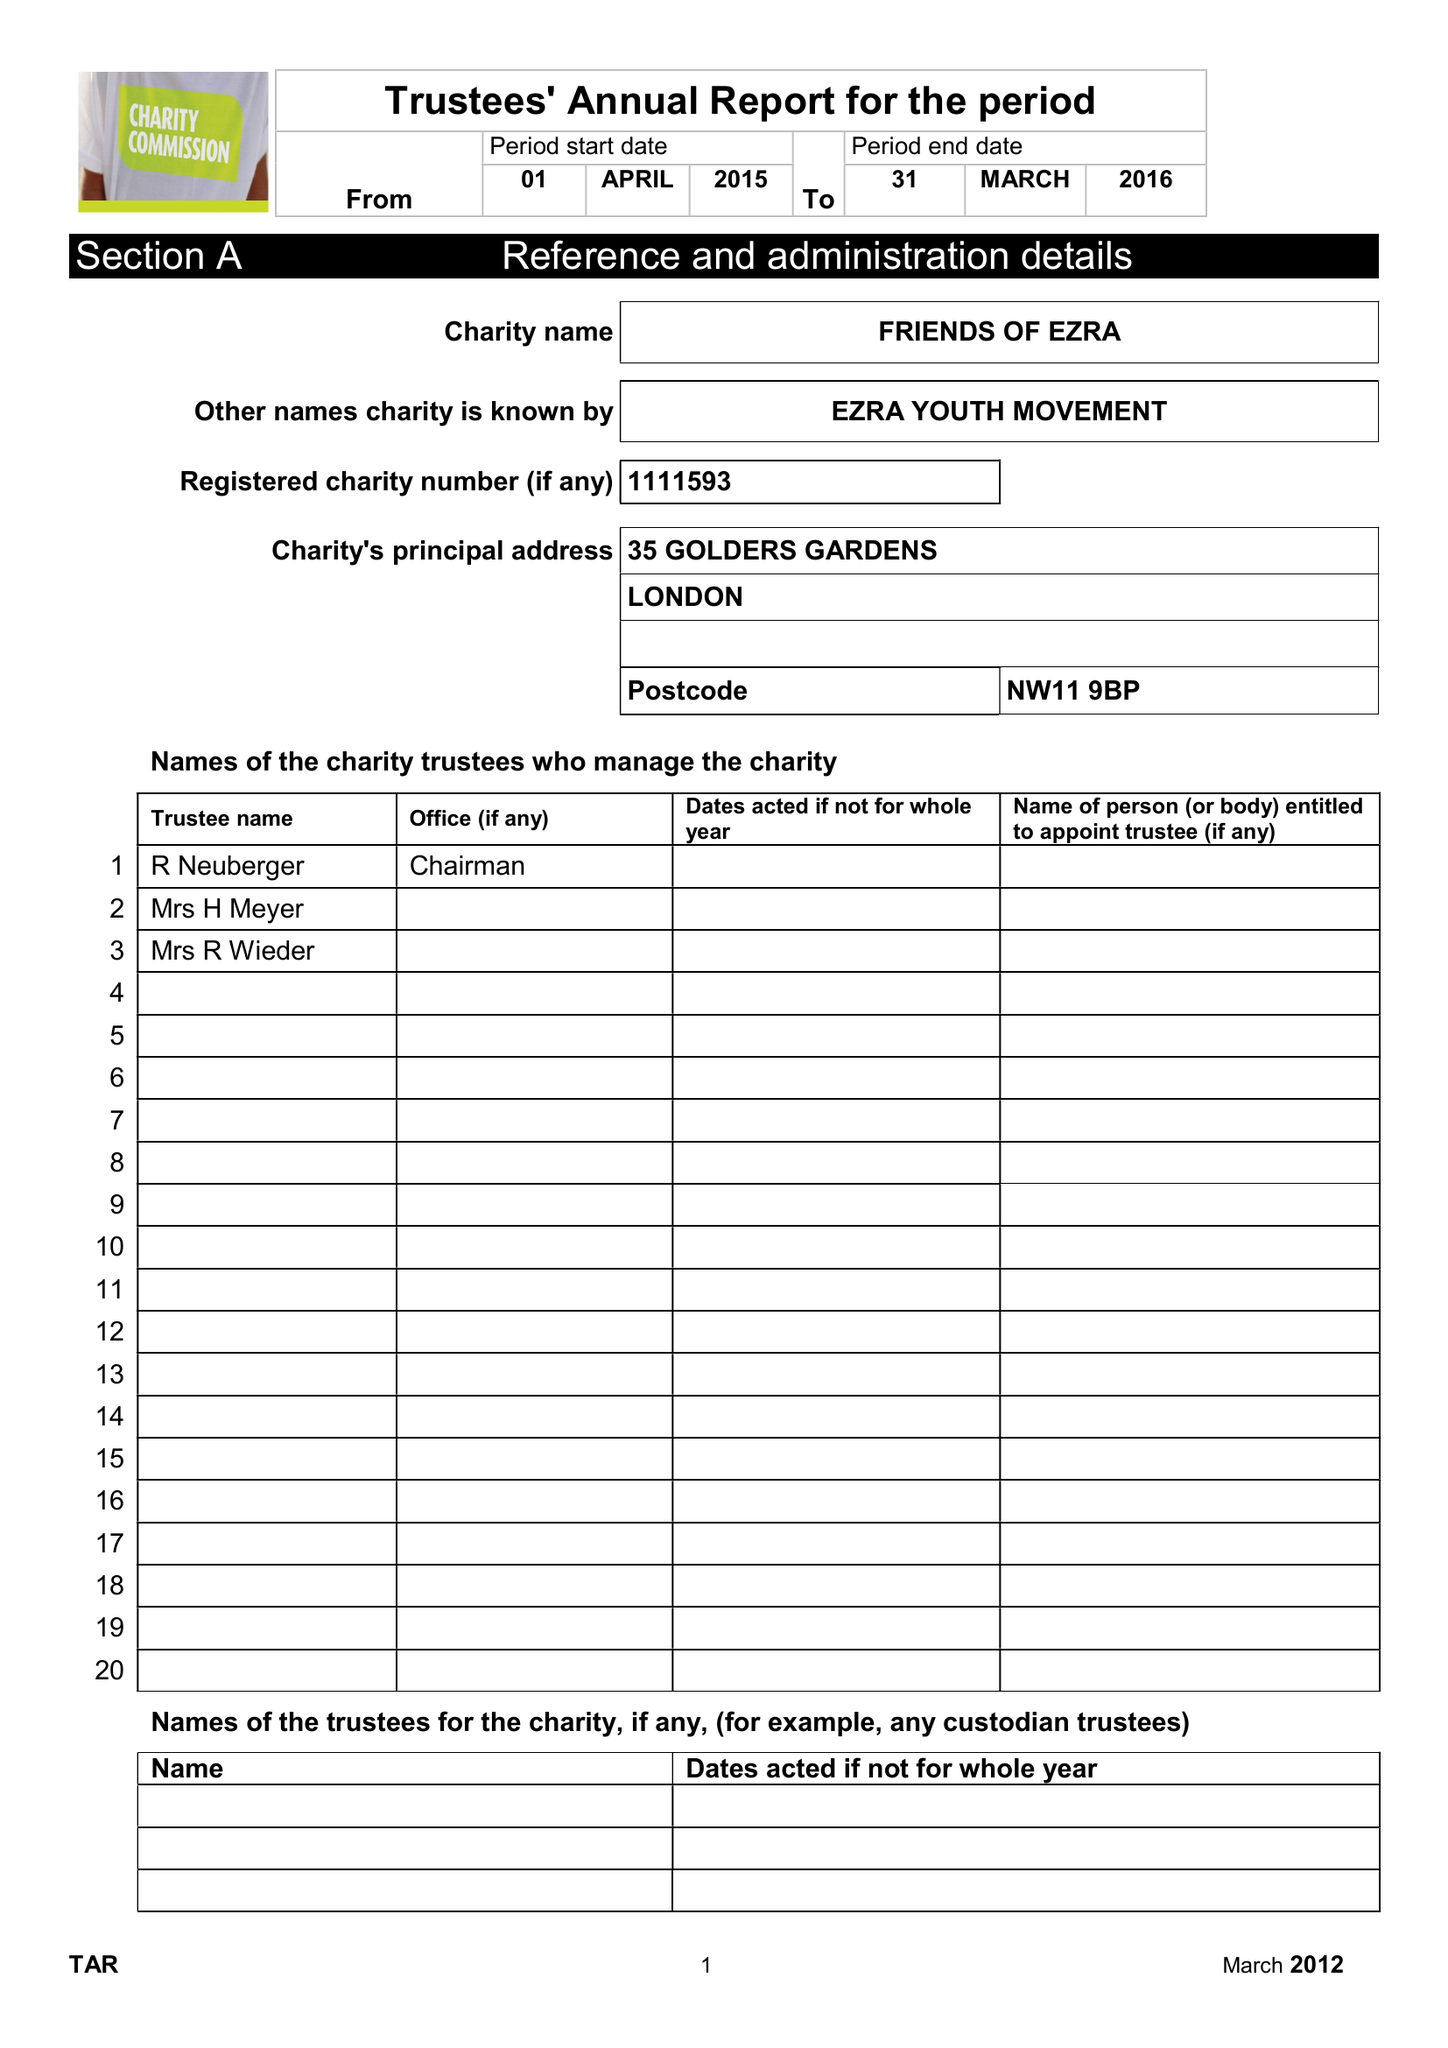What is the value for the address__postcode?
Answer the question using a single word or phrase. NW11 9BP 